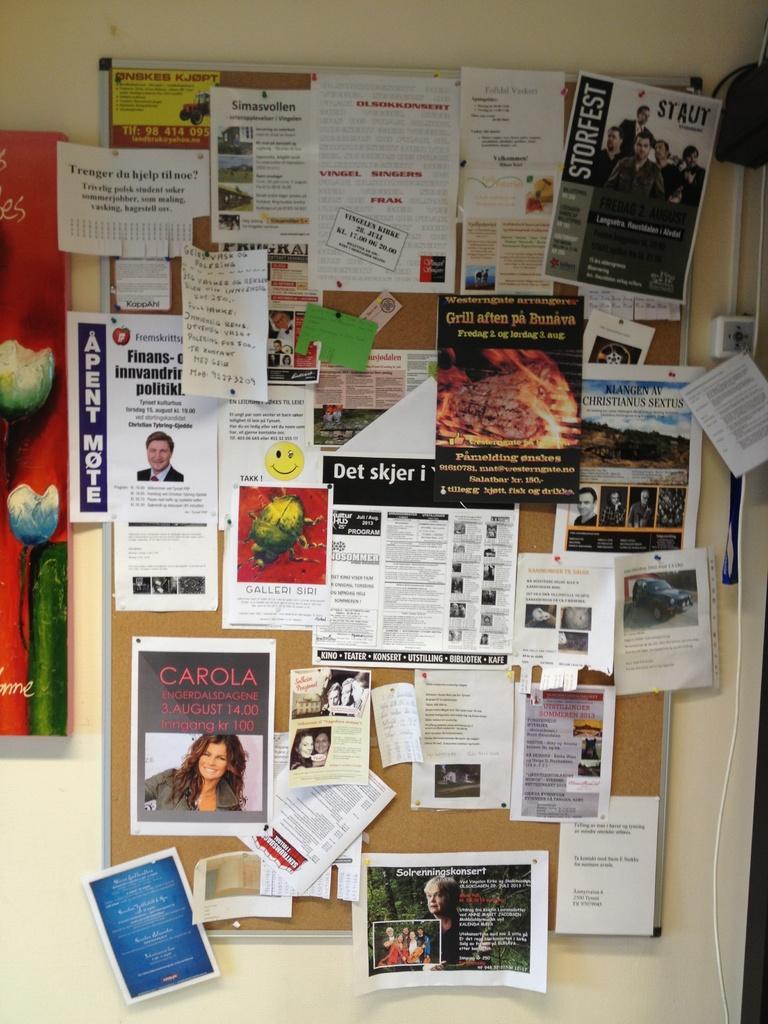In one or two sentences, can you explain what this image depicts? There is a notice board and plenty of posters are stick to the notice board,in the background there is a wall. 